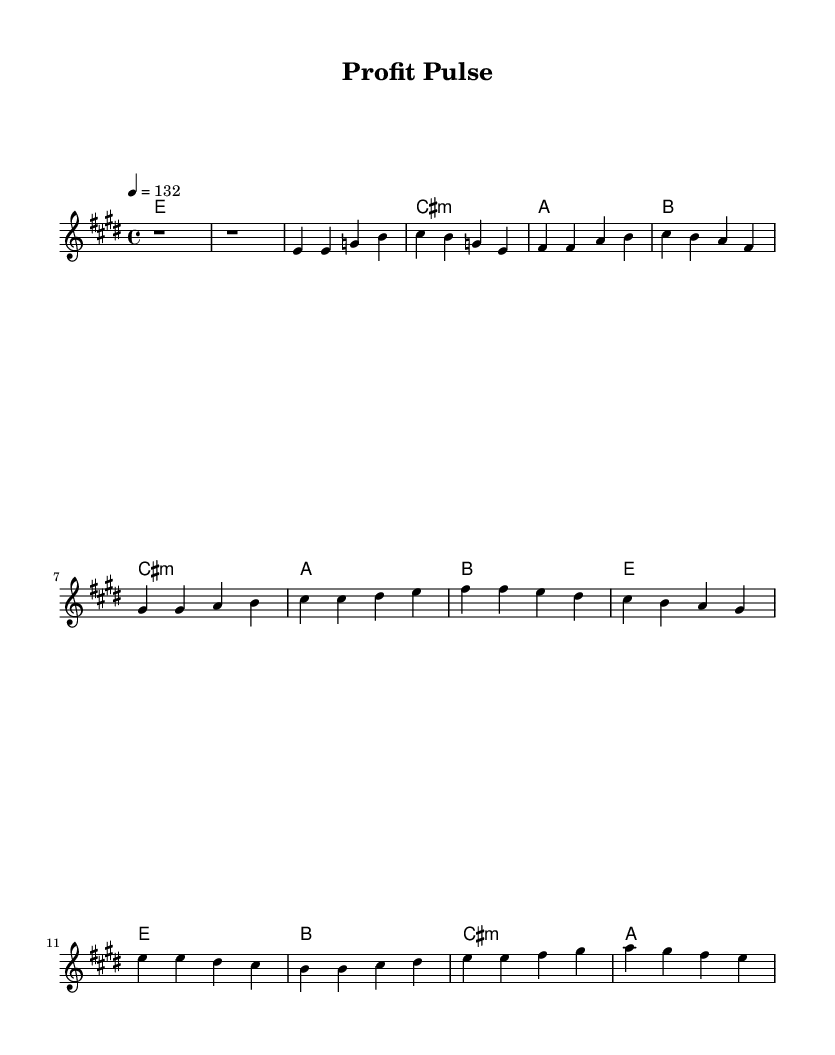What is the key signature of this music? The key signature is E major, which has four sharps: F#, C#, G#, and D#.
Answer: E major What is the time signature of this music? The time signature is 4/4, indicating four beats in each measure and a quarter note gets one beat.
Answer: 4/4 What is the tempo marking for this piece? The tempo marking indicates a speed of 132 beats per minute, denoted by the term "4 = 132".
Answer: 132 How many measures are in the verse section? The verse section consists of four measures, as indicated by the melody notation showing four separate groupings of notes.
Answer: 4 What is the chord that accompanies the chorus? The chorus is primarily accompanied by the E major chord, followed by B major, C# minor, and A major chords.
Answer: E major What type of rhythmic feel does the song likely have? Based on the tempo and the dance track nature of this K-Pop piece, it likely has a driving and energetic rhythmic feel typical of fast-paced dance music.
Answer: Driving Which musical section likely serves as the climax of the piece? The chorus typically serves as the climax in modern pop music, including K-Pop, due to its repetitive and catchy nature, making it more impactful.
Answer: Chorus 